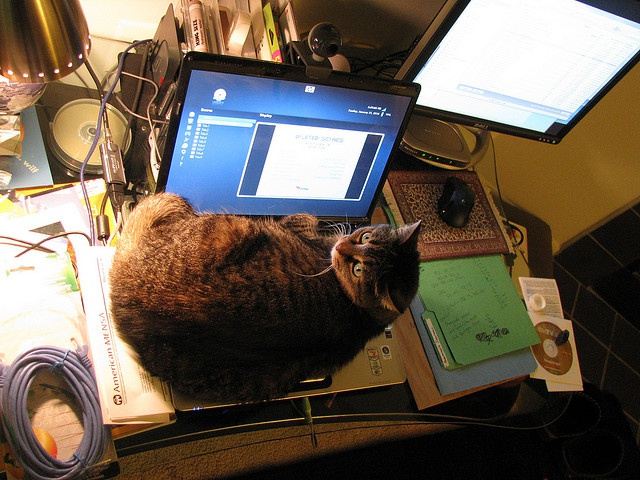Describe the objects in this image and their specific colors. I can see cat in black, maroon, brown, and tan tones, laptop in black, white, lightblue, and gray tones, tv in black, white, lightblue, and gray tones, tv in black, white, lightblue, and navy tones, and book in black, darkgreen, and green tones in this image. 